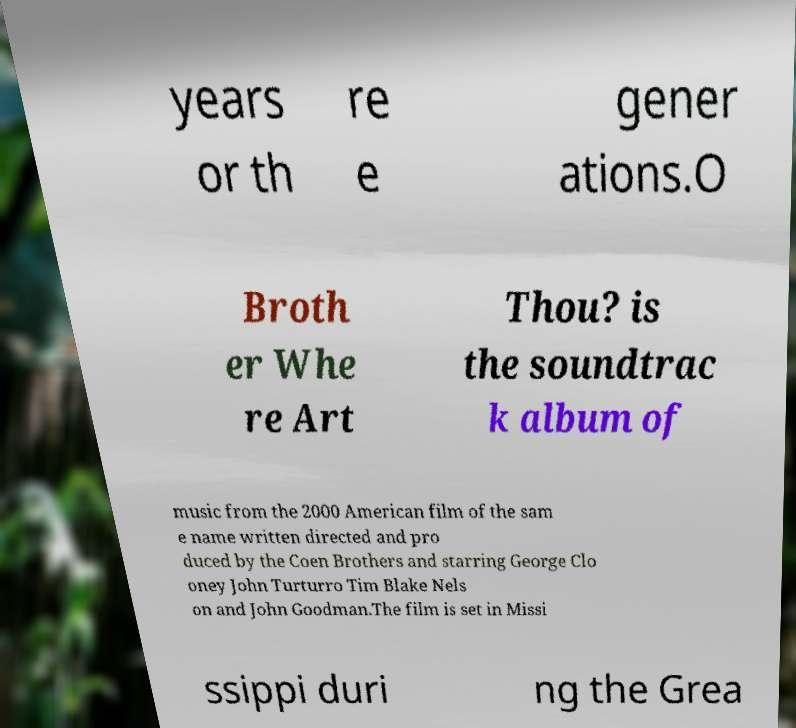Please read and relay the text visible in this image. What does it say? years or th re e gener ations.O Broth er Whe re Art Thou? is the soundtrac k album of music from the 2000 American film of the sam e name written directed and pro duced by the Coen Brothers and starring George Clo oney John Turturro Tim Blake Nels on and John Goodman.The film is set in Missi ssippi duri ng the Grea 